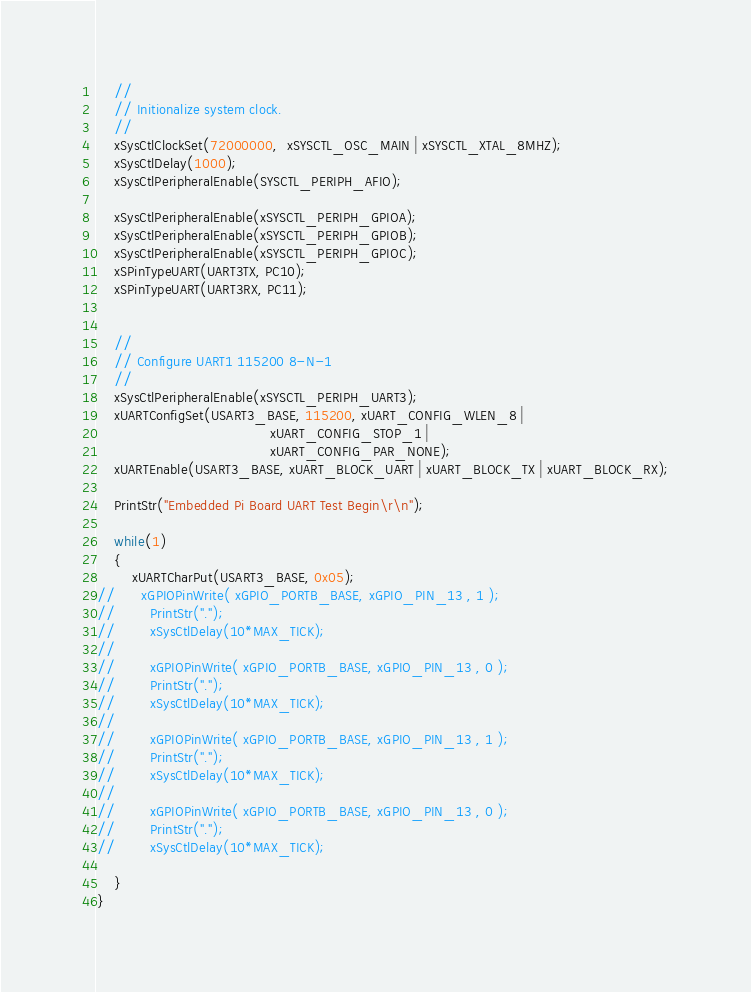<code> <loc_0><loc_0><loc_500><loc_500><_C_>    //
    // Initionalize system clock.
    //
    xSysCtlClockSet(72000000,  xSYSCTL_OSC_MAIN | xSYSCTL_XTAL_8MHZ);
    xSysCtlDelay(1000);
    xSysCtlPeripheralEnable(SYSCTL_PERIPH_AFIO);
	
    xSysCtlPeripheralEnable(xSYSCTL_PERIPH_GPIOA);
    xSysCtlPeripheralEnable(xSYSCTL_PERIPH_GPIOB);
    xSysCtlPeripheralEnable(xSYSCTL_PERIPH_GPIOC);
    xSPinTypeUART(UART3TX, PC10);
    xSPinTypeUART(UART3RX, PC11);

	
    //
    // Configure UART1 115200 8-N-1
    //
    xSysCtlPeripheralEnable(xSYSCTL_PERIPH_UART3);
    xUARTConfigSet(USART3_BASE, 115200, xUART_CONFIG_WLEN_8 |
    		                            xUART_CONFIG_STOP_1 |
    		                            xUART_CONFIG_PAR_NONE);
    xUARTEnable(USART3_BASE, xUART_BLOCK_UART | xUART_BLOCK_TX | xUART_BLOCK_RX);
	
    PrintStr("Embedded Pi Board UART Test Begin\r\n");

    while(1)
    {
    	xUARTCharPut(USART3_BASE, 0x05);
//    	xGPIOPinWrite( xGPIO_PORTB_BASE, xGPIO_PIN_13 , 1 );
//        PrintStr(".");
//        xSysCtlDelay(10*MAX_TICK);
//
//        xGPIOPinWrite( xGPIO_PORTB_BASE, xGPIO_PIN_13 , 0 );
//        PrintStr(".");
//        xSysCtlDelay(10*MAX_TICK);
//
//        xGPIOPinWrite( xGPIO_PORTB_BASE, xGPIO_PIN_13 , 1 );
//        PrintStr(".");
//        xSysCtlDelay(10*MAX_TICK);
//
//        xGPIOPinWrite( xGPIO_PORTB_BASE, xGPIO_PIN_13 , 0 );
//        PrintStr(".");
//        xSysCtlDelay(10*MAX_TICK);

    }
}
</code> 